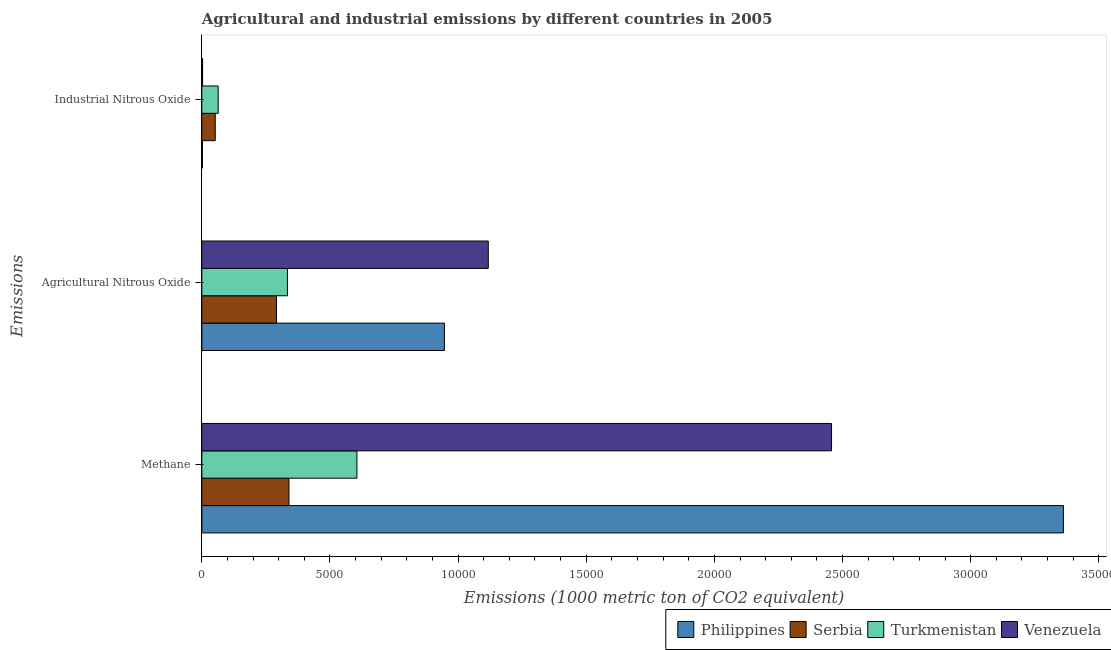Are the number of bars per tick equal to the number of legend labels?
Your answer should be very brief. Yes. How many bars are there on the 2nd tick from the top?
Keep it short and to the point. 4. How many bars are there on the 3rd tick from the bottom?
Your answer should be compact. 4. What is the label of the 2nd group of bars from the top?
Make the answer very short. Agricultural Nitrous Oxide. What is the amount of industrial nitrous oxide emissions in Philippines?
Offer a very short reply. 24. Across all countries, what is the maximum amount of industrial nitrous oxide emissions?
Offer a terse response. 637.2. Across all countries, what is the minimum amount of methane emissions?
Offer a very short reply. 3399.6. In which country was the amount of industrial nitrous oxide emissions maximum?
Your answer should be very brief. Turkmenistan. What is the total amount of methane emissions in the graph?
Offer a terse response. 6.76e+04. What is the difference between the amount of agricultural nitrous oxide emissions in Venezuela and that in Turkmenistan?
Provide a short and direct response. 7836.7. What is the difference between the amount of industrial nitrous oxide emissions in Philippines and the amount of agricultural nitrous oxide emissions in Turkmenistan?
Make the answer very short. -3317.3. What is the average amount of agricultural nitrous oxide emissions per country?
Offer a very short reply. 6724.55. What is the difference between the amount of agricultural nitrous oxide emissions and amount of industrial nitrous oxide emissions in Venezuela?
Your response must be concise. 1.11e+04. What is the ratio of the amount of methane emissions in Serbia to that in Philippines?
Offer a terse response. 0.1. Is the amount of methane emissions in Serbia less than that in Turkmenistan?
Provide a succinct answer. Yes. Is the difference between the amount of methane emissions in Philippines and Serbia greater than the difference between the amount of industrial nitrous oxide emissions in Philippines and Serbia?
Make the answer very short. Yes. What is the difference between the highest and the second highest amount of industrial nitrous oxide emissions?
Make the answer very short. 114.9. What is the difference between the highest and the lowest amount of methane emissions?
Keep it short and to the point. 3.02e+04. In how many countries, is the amount of industrial nitrous oxide emissions greater than the average amount of industrial nitrous oxide emissions taken over all countries?
Your answer should be compact. 2. Is the sum of the amount of industrial nitrous oxide emissions in Venezuela and Serbia greater than the maximum amount of agricultural nitrous oxide emissions across all countries?
Ensure brevity in your answer.  No. What does the 3rd bar from the top in Industrial Nitrous Oxide represents?
Offer a terse response. Serbia. What does the 3rd bar from the bottom in Methane represents?
Keep it short and to the point. Turkmenistan. Is it the case that in every country, the sum of the amount of methane emissions and amount of agricultural nitrous oxide emissions is greater than the amount of industrial nitrous oxide emissions?
Provide a succinct answer. Yes. How many bars are there?
Make the answer very short. 12. What is the difference between two consecutive major ticks on the X-axis?
Your answer should be very brief. 5000. Are the values on the major ticks of X-axis written in scientific E-notation?
Provide a short and direct response. No. Does the graph contain any zero values?
Give a very brief answer. No. Does the graph contain grids?
Your answer should be compact. No. Where does the legend appear in the graph?
Ensure brevity in your answer.  Bottom right. How many legend labels are there?
Your answer should be very brief. 4. How are the legend labels stacked?
Give a very brief answer. Horizontal. What is the title of the graph?
Provide a short and direct response. Agricultural and industrial emissions by different countries in 2005. What is the label or title of the X-axis?
Ensure brevity in your answer.  Emissions (1000 metric ton of CO2 equivalent). What is the label or title of the Y-axis?
Your answer should be very brief. Emissions. What is the Emissions (1000 metric ton of CO2 equivalent) of Philippines in Methane?
Provide a short and direct response. 3.36e+04. What is the Emissions (1000 metric ton of CO2 equivalent) of Serbia in Methane?
Make the answer very short. 3399.6. What is the Emissions (1000 metric ton of CO2 equivalent) of Turkmenistan in Methane?
Your response must be concise. 6052.3. What is the Emissions (1000 metric ton of CO2 equivalent) of Venezuela in Methane?
Give a very brief answer. 2.46e+04. What is the Emissions (1000 metric ton of CO2 equivalent) of Philippines in Agricultural Nitrous Oxide?
Provide a short and direct response. 9465.1. What is the Emissions (1000 metric ton of CO2 equivalent) in Serbia in Agricultural Nitrous Oxide?
Provide a succinct answer. 2913.8. What is the Emissions (1000 metric ton of CO2 equivalent) of Turkmenistan in Agricultural Nitrous Oxide?
Offer a very short reply. 3341.3. What is the Emissions (1000 metric ton of CO2 equivalent) of Venezuela in Agricultural Nitrous Oxide?
Your response must be concise. 1.12e+04. What is the Emissions (1000 metric ton of CO2 equivalent) in Philippines in Industrial Nitrous Oxide?
Your answer should be compact. 24. What is the Emissions (1000 metric ton of CO2 equivalent) in Serbia in Industrial Nitrous Oxide?
Keep it short and to the point. 522.3. What is the Emissions (1000 metric ton of CO2 equivalent) of Turkmenistan in Industrial Nitrous Oxide?
Offer a terse response. 637.2. What is the Emissions (1000 metric ton of CO2 equivalent) of Venezuela in Industrial Nitrous Oxide?
Ensure brevity in your answer.  30.1. Across all Emissions, what is the maximum Emissions (1000 metric ton of CO2 equivalent) of Philippines?
Give a very brief answer. 3.36e+04. Across all Emissions, what is the maximum Emissions (1000 metric ton of CO2 equivalent) of Serbia?
Offer a terse response. 3399.6. Across all Emissions, what is the maximum Emissions (1000 metric ton of CO2 equivalent) in Turkmenistan?
Give a very brief answer. 6052.3. Across all Emissions, what is the maximum Emissions (1000 metric ton of CO2 equivalent) in Venezuela?
Give a very brief answer. 2.46e+04. Across all Emissions, what is the minimum Emissions (1000 metric ton of CO2 equivalent) in Philippines?
Your response must be concise. 24. Across all Emissions, what is the minimum Emissions (1000 metric ton of CO2 equivalent) in Serbia?
Keep it short and to the point. 522.3. Across all Emissions, what is the minimum Emissions (1000 metric ton of CO2 equivalent) of Turkmenistan?
Ensure brevity in your answer.  637.2. Across all Emissions, what is the minimum Emissions (1000 metric ton of CO2 equivalent) of Venezuela?
Provide a succinct answer. 30.1. What is the total Emissions (1000 metric ton of CO2 equivalent) of Philippines in the graph?
Offer a terse response. 4.31e+04. What is the total Emissions (1000 metric ton of CO2 equivalent) in Serbia in the graph?
Offer a terse response. 6835.7. What is the total Emissions (1000 metric ton of CO2 equivalent) of Turkmenistan in the graph?
Make the answer very short. 1.00e+04. What is the total Emissions (1000 metric ton of CO2 equivalent) in Venezuela in the graph?
Make the answer very short. 3.58e+04. What is the difference between the Emissions (1000 metric ton of CO2 equivalent) of Philippines in Methane and that in Agricultural Nitrous Oxide?
Your answer should be very brief. 2.42e+04. What is the difference between the Emissions (1000 metric ton of CO2 equivalent) in Serbia in Methane and that in Agricultural Nitrous Oxide?
Ensure brevity in your answer.  485.8. What is the difference between the Emissions (1000 metric ton of CO2 equivalent) of Turkmenistan in Methane and that in Agricultural Nitrous Oxide?
Keep it short and to the point. 2711. What is the difference between the Emissions (1000 metric ton of CO2 equivalent) in Venezuela in Methane and that in Agricultural Nitrous Oxide?
Provide a short and direct response. 1.34e+04. What is the difference between the Emissions (1000 metric ton of CO2 equivalent) of Philippines in Methane and that in Industrial Nitrous Oxide?
Offer a terse response. 3.36e+04. What is the difference between the Emissions (1000 metric ton of CO2 equivalent) in Serbia in Methane and that in Industrial Nitrous Oxide?
Offer a very short reply. 2877.3. What is the difference between the Emissions (1000 metric ton of CO2 equivalent) in Turkmenistan in Methane and that in Industrial Nitrous Oxide?
Offer a terse response. 5415.1. What is the difference between the Emissions (1000 metric ton of CO2 equivalent) of Venezuela in Methane and that in Industrial Nitrous Oxide?
Offer a terse response. 2.45e+04. What is the difference between the Emissions (1000 metric ton of CO2 equivalent) of Philippines in Agricultural Nitrous Oxide and that in Industrial Nitrous Oxide?
Ensure brevity in your answer.  9441.1. What is the difference between the Emissions (1000 metric ton of CO2 equivalent) of Serbia in Agricultural Nitrous Oxide and that in Industrial Nitrous Oxide?
Your answer should be compact. 2391.5. What is the difference between the Emissions (1000 metric ton of CO2 equivalent) of Turkmenistan in Agricultural Nitrous Oxide and that in Industrial Nitrous Oxide?
Your answer should be very brief. 2704.1. What is the difference between the Emissions (1000 metric ton of CO2 equivalent) in Venezuela in Agricultural Nitrous Oxide and that in Industrial Nitrous Oxide?
Your answer should be very brief. 1.11e+04. What is the difference between the Emissions (1000 metric ton of CO2 equivalent) of Philippines in Methane and the Emissions (1000 metric ton of CO2 equivalent) of Serbia in Agricultural Nitrous Oxide?
Your answer should be very brief. 3.07e+04. What is the difference between the Emissions (1000 metric ton of CO2 equivalent) in Philippines in Methane and the Emissions (1000 metric ton of CO2 equivalent) in Turkmenistan in Agricultural Nitrous Oxide?
Offer a very short reply. 3.03e+04. What is the difference between the Emissions (1000 metric ton of CO2 equivalent) of Philippines in Methane and the Emissions (1000 metric ton of CO2 equivalent) of Venezuela in Agricultural Nitrous Oxide?
Offer a very short reply. 2.24e+04. What is the difference between the Emissions (1000 metric ton of CO2 equivalent) of Serbia in Methane and the Emissions (1000 metric ton of CO2 equivalent) of Turkmenistan in Agricultural Nitrous Oxide?
Keep it short and to the point. 58.3. What is the difference between the Emissions (1000 metric ton of CO2 equivalent) in Serbia in Methane and the Emissions (1000 metric ton of CO2 equivalent) in Venezuela in Agricultural Nitrous Oxide?
Your response must be concise. -7778.4. What is the difference between the Emissions (1000 metric ton of CO2 equivalent) in Turkmenistan in Methane and the Emissions (1000 metric ton of CO2 equivalent) in Venezuela in Agricultural Nitrous Oxide?
Provide a short and direct response. -5125.7. What is the difference between the Emissions (1000 metric ton of CO2 equivalent) of Philippines in Methane and the Emissions (1000 metric ton of CO2 equivalent) of Serbia in Industrial Nitrous Oxide?
Keep it short and to the point. 3.31e+04. What is the difference between the Emissions (1000 metric ton of CO2 equivalent) in Philippines in Methane and the Emissions (1000 metric ton of CO2 equivalent) in Turkmenistan in Industrial Nitrous Oxide?
Give a very brief answer. 3.30e+04. What is the difference between the Emissions (1000 metric ton of CO2 equivalent) of Philippines in Methane and the Emissions (1000 metric ton of CO2 equivalent) of Venezuela in Industrial Nitrous Oxide?
Offer a terse response. 3.36e+04. What is the difference between the Emissions (1000 metric ton of CO2 equivalent) in Serbia in Methane and the Emissions (1000 metric ton of CO2 equivalent) in Turkmenistan in Industrial Nitrous Oxide?
Make the answer very short. 2762.4. What is the difference between the Emissions (1000 metric ton of CO2 equivalent) in Serbia in Methane and the Emissions (1000 metric ton of CO2 equivalent) in Venezuela in Industrial Nitrous Oxide?
Provide a succinct answer. 3369.5. What is the difference between the Emissions (1000 metric ton of CO2 equivalent) in Turkmenistan in Methane and the Emissions (1000 metric ton of CO2 equivalent) in Venezuela in Industrial Nitrous Oxide?
Your answer should be compact. 6022.2. What is the difference between the Emissions (1000 metric ton of CO2 equivalent) of Philippines in Agricultural Nitrous Oxide and the Emissions (1000 metric ton of CO2 equivalent) of Serbia in Industrial Nitrous Oxide?
Keep it short and to the point. 8942.8. What is the difference between the Emissions (1000 metric ton of CO2 equivalent) of Philippines in Agricultural Nitrous Oxide and the Emissions (1000 metric ton of CO2 equivalent) of Turkmenistan in Industrial Nitrous Oxide?
Your answer should be compact. 8827.9. What is the difference between the Emissions (1000 metric ton of CO2 equivalent) of Philippines in Agricultural Nitrous Oxide and the Emissions (1000 metric ton of CO2 equivalent) of Venezuela in Industrial Nitrous Oxide?
Give a very brief answer. 9435. What is the difference between the Emissions (1000 metric ton of CO2 equivalent) of Serbia in Agricultural Nitrous Oxide and the Emissions (1000 metric ton of CO2 equivalent) of Turkmenistan in Industrial Nitrous Oxide?
Your response must be concise. 2276.6. What is the difference between the Emissions (1000 metric ton of CO2 equivalent) in Serbia in Agricultural Nitrous Oxide and the Emissions (1000 metric ton of CO2 equivalent) in Venezuela in Industrial Nitrous Oxide?
Offer a terse response. 2883.7. What is the difference between the Emissions (1000 metric ton of CO2 equivalent) of Turkmenistan in Agricultural Nitrous Oxide and the Emissions (1000 metric ton of CO2 equivalent) of Venezuela in Industrial Nitrous Oxide?
Your response must be concise. 3311.2. What is the average Emissions (1000 metric ton of CO2 equivalent) in Philippines per Emissions?
Your answer should be very brief. 1.44e+04. What is the average Emissions (1000 metric ton of CO2 equivalent) in Serbia per Emissions?
Make the answer very short. 2278.57. What is the average Emissions (1000 metric ton of CO2 equivalent) in Turkmenistan per Emissions?
Ensure brevity in your answer.  3343.6. What is the average Emissions (1000 metric ton of CO2 equivalent) of Venezuela per Emissions?
Offer a very short reply. 1.19e+04. What is the difference between the Emissions (1000 metric ton of CO2 equivalent) in Philippines and Emissions (1000 metric ton of CO2 equivalent) in Serbia in Methane?
Your answer should be very brief. 3.02e+04. What is the difference between the Emissions (1000 metric ton of CO2 equivalent) in Philippines and Emissions (1000 metric ton of CO2 equivalent) in Turkmenistan in Methane?
Keep it short and to the point. 2.76e+04. What is the difference between the Emissions (1000 metric ton of CO2 equivalent) of Philippines and Emissions (1000 metric ton of CO2 equivalent) of Venezuela in Methane?
Provide a short and direct response. 9047.8. What is the difference between the Emissions (1000 metric ton of CO2 equivalent) of Serbia and Emissions (1000 metric ton of CO2 equivalent) of Turkmenistan in Methane?
Provide a succinct answer. -2652.7. What is the difference between the Emissions (1000 metric ton of CO2 equivalent) of Serbia and Emissions (1000 metric ton of CO2 equivalent) of Venezuela in Methane?
Offer a very short reply. -2.12e+04. What is the difference between the Emissions (1000 metric ton of CO2 equivalent) in Turkmenistan and Emissions (1000 metric ton of CO2 equivalent) in Venezuela in Methane?
Keep it short and to the point. -1.85e+04. What is the difference between the Emissions (1000 metric ton of CO2 equivalent) of Philippines and Emissions (1000 metric ton of CO2 equivalent) of Serbia in Agricultural Nitrous Oxide?
Your answer should be compact. 6551.3. What is the difference between the Emissions (1000 metric ton of CO2 equivalent) in Philippines and Emissions (1000 metric ton of CO2 equivalent) in Turkmenistan in Agricultural Nitrous Oxide?
Offer a terse response. 6123.8. What is the difference between the Emissions (1000 metric ton of CO2 equivalent) in Philippines and Emissions (1000 metric ton of CO2 equivalent) in Venezuela in Agricultural Nitrous Oxide?
Your answer should be compact. -1712.9. What is the difference between the Emissions (1000 metric ton of CO2 equivalent) in Serbia and Emissions (1000 metric ton of CO2 equivalent) in Turkmenistan in Agricultural Nitrous Oxide?
Make the answer very short. -427.5. What is the difference between the Emissions (1000 metric ton of CO2 equivalent) in Serbia and Emissions (1000 metric ton of CO2 equivalent) in Venezuela in Agricultural Nitrous Oxide?
Provide a succinct answer. -8264.2. What is the difference between the Emissions (1000 metric ton of CO2 equivalent) of Turkmenistan and Emissions (1000 metric ton of CO2 equivalent) of Venezuela in Agricultural Nitrous Oxide?
Provide a short and direct response. -7836.7. What is the difference between the Emissions (1000 metric ton of CO2 equivalent) of Philippines and Emissions (1000 metric ton of CO2 equivalent) of Serbia in Industrial Nitrous Oxide?
Provide a short and direct response. -498.3. What is the difference between the Emissions (1000 metric ton of CO2 equivalent) of Philippines and Emissions (1000 metric ton of CO2 equivalent) of Turkmenistan in Industrial Nitrous Oxide?
Your answer should be compact. -613.2. What is the difference between the Emissions (1000 metric ton of CO2 equivalent) in Philippines and Emissions (1000 metric ton of CO2 equivalent) in Venezuela in Industrial Nitrous Oxide?
Make the answer very short. -6.1. What is the difference between the Emissions (1000 metric ton of CO2 equivalent) of Serbia and Emissions (1000 metric ton of CO2 equivalent) of Turkmenistan in Industrial Nitrous Oxide?
Offer a very short reply. -114.9. What is the difference between the Emissions (1000 metric ton of CO2 equivalent) in Serbia and Emissions (1000 metric ton of CO2 equivalent) in Venezuela in Industrial Nitrous Oxide?
Your answer should be very brief. 492.2. What is the difference between the Emissions (1000 metric ton of CO2 equivalent) in Turkmenistan and Emissions (1000 metric ton of CO2 equivalent) in Venezuela in Industrial Nitrous Oxide?
Your answer should be very brief. 607.1. What is the ratio of the Emissions (1000 metric ton of CO2 equivalent) in Philippines in Methane to that in Agricultural Nitrous Oxide?
Make the answer very short. 3.55. What is the ratio of the Emissions (1000 metric ton of CO2 equivalent) of Serbia in Methane to that in Agricultural Nitrous Oxide?
Give a very brief answer. 1.17. What is the ratio of the Emissions (1000 metric ton of CO2 equivalent) in Turkmenistan in Methane to that in Agricultural Nitrous Oxide?
Offer a very short reply. 1.81. What is the ratio of the Emissions (1000 metric ton of CO2 equivalent) in Venezuela in Methane to that in Agricultural Nitrous Oxide?
Provide a short and direct response. 2.2. What is the ratio of the Emissions (1000 metric ton of CO2 equivalent) in Philippines in Methane to that in Industrial Nitrous Oxide?
Your answer should be very brief. 1400.84. What is the ratio of the Emissions (1000 metric ton of CO2 equivalent) of Serbia in Methane to that in Industrial Nitrous Oxide?
Your answer should be very brief. 6.51. What is the ratio of the Emissions (1000 metric ton of CO2 equivalent) in Turkmenistan in Methane to that in Industrial Nitrous Oxide?
Ensure brevity in your answer.  9.5. What is the ratio of the Emissions (1000 metric ton of CO2 equivalent) in Venezuela in Methane to that in Industrial Nitrous Oxide?
Provide a succinct answer. 816.36. What is the ratio of the Emissions (1000 metric ton of CO2 equivalent) of Philippines in Agricultural Nitrous Oxide to that in Industrial Nitrous Oxide?
Ensure brevity in your answer.  394.38. What is the ratio of the Emissions (1000 metric ton of CO2 equivalent) of Serbia in Agricultural Nitrous Oxide to that in Industrial Nitrous Oxide?
Your response must be concise. 5.58. What is the ratio of the Emissions (1000 metric ton of CO2 equivalent) in Turkmenistan in Agricultural Nitrous Oxide to that in Industrial Nitrous Oxide?
Your answer should be very brief. 5.24. What is the ratio of the Emissions (1000 metric ton of CO2 equivalent) in Venezuela in Agricultural Nitrous Oxide to that in Industrial Nitrous Oxide?
Make the answer very short. 371.36. What is the difference between the highest and the second highest Emissions (1000 metric ton of CO2 equivalent) in Philippines?
Ensure brevity in your answer.  2.42e+04. What is the difference between the highest and the second highest Emissions (1000 metric ton of CO2 equivalent) of Serbia?
Your response must be concise. 485.8. What is the difference between the highest and the second highest Emissions (1000 metric ton of CO2 equivalent) in Turkmenistan?
Provide a short and direct response. 2711. What is the difference between the highest and the second highest Emissions (1000 metric ton of CO2 equivalent) of Venezuela?
Provide a short and direct response. 1.34e+04. What is the difference between the highest and the lowest Emissions (1000 metric ton of CO2 equivalent) of Philippines?
Make the answer very short. 3.36e+04. What is the difference between the highest and the lowest Emissions (1000 metric ton of CO2 equivalent) of Serbia?
Keep it short and to the point. 2877.3. What is the difference between the highest and the lowest Emissions (1000 metric ton of CO2 equivalent) of Turkmenistan?
Keep it short and to the point. 5415.1. What is the difference between the highest and the lowest Emissions (1000 metric ton of CO2 equivalent) of Venezuela?
Provide a short and direct response. 2.45e+04. 